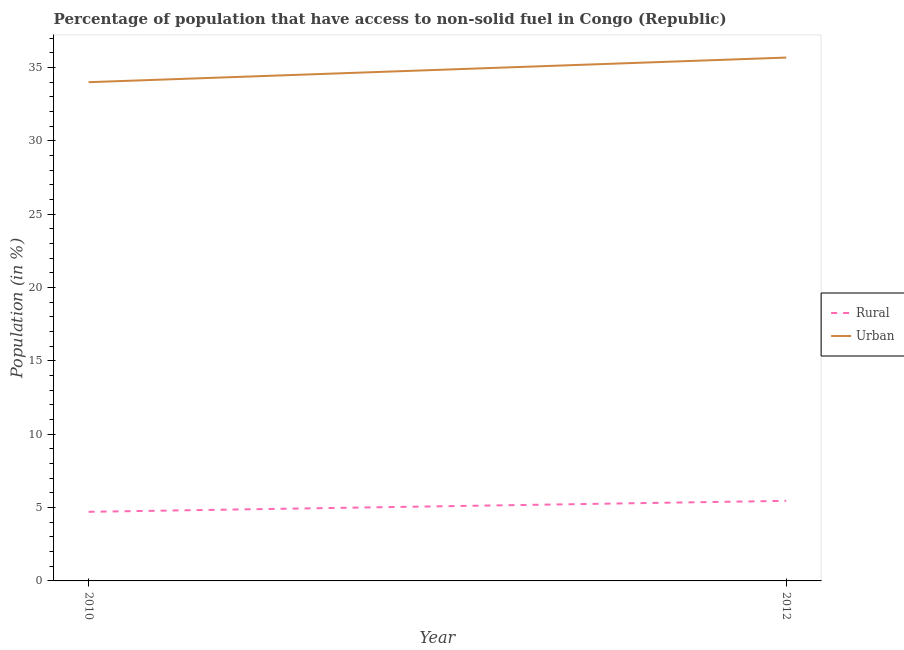How many different coloured lines are there?
Provide a short and direct response. 2. What is the urban population in 2010?
Make the answer very short. 34.01. Across all years, what is the maximum rural population?
Ensure brevity in your answer.  5.46. Across all years, what is the minimum rural population?
Keep it short and to the point. 4.71. In which year was the rural population minimum?
Your answer should be compact. 2010. What is the total rural population in the graph?
Your response must be concise. 10.17. What is the difference between the rural population in 2010 and that in 2012?
Ensure brevity in your answer.  -0.75. What is the difference between the rural population in 2012 and the urban population in 2010?
Provide a short and direct response. -28.55. What is the average urban population per year?
Offer a very short reply. 34.85. In the year 2012, what is the difference between the urban population and rural population?
Ensure brevity in your answer.  30.23. In how many years, is the rural population greater than 4 %?
Make the answer very short. 2. What is the ratio of the rural population in 2010 to that in 2012?
Make the answer very short. 0.86. Is the urban population in 2010 less than that in 2012?
Your answer should be very brief. Yes. Is the rural population strictly greater than the urban population over the years?
Make the answer very short. No. Is the rural population strictly less than the urban population over the years?
Your answer should be very brief. Yes. How many lines are there?
Offer a terse response. 2. What is the difference between two consecutive major ticks on the Y-axis?
Your answer should be compact. 5. How many legend labels are there?
Provide a succinct answer. 2. How are the legend labels stacked?
Your answer should be very brief. Vertical. What is the title of the graph?
Offer a very short reply. Percentage of population that have access to non-solid fuel in Congo (Republic). Does "Under-5(male)" appear as one of the legend labels in the graph?
Give a very brief answer. No. What is the Population (in %) in Rural in 2010?
Make the answer very short. 4.71. What is the Population (in %) of Urban in 2010?
Make the answer very short. 34.01. What is the Population (in %) of Rural in 2012?
Your answer should be very brief. 5.46. What is the Population (in %) in Urban in 2012?
Your answer should be compact. 35.69. Across all years, what is the maximum Population (in %) of Rural?
Provide a succinct answer. 5.46. Across all years, what is the maximum Population (in %) in Urban?
Ensure brevity in your answer.  35.69. Across all years, what is the minimum Population (in %) of Rural?
Your answer should be very brief. 4.71. Across all years, what is the minimum Population (in %) of Urban?
Offer a very short reply. 34.01. What is the total Population (in %) in Rural in the graph?
Provide a succinct answer. 10.17. What is the total Population (in %) of Urban in the graph?
Keep it short and to the point. 69.69. What is the difference between the Population (in %) in Rural in 2010 and that in 2012?
Your answer should be very brief. -0.75. What is the difference between the Population (in %) of Urban in 2010 and that in 2012?
Your answer should be very brief. -1.68. What is the difference between the Population (in %) of Rural in 2010 and the Population (in %) of Urban in 2012?
Offer a terse response. -30.97. What is the average Population (in %) of Rural per year?
Your answer should be very brief. 5.09. What is the average Population (in %) in Urban per year?
Provide a succinct answer. 34.85. In the year 2010, what is the difference between the Population (in %) of Rural and Population (in %) of Urban?
Keep it short and to the point. -29.3. In the year 2012, what is the difference between the Population (in %) in Rural and Population (in %) in Urban?
Provide a succinct answer. -30.23. What is the ratio of the Population (in %) in Rural in 2010 to that in 2012?
Offer a terse response. 0.86. What is the ratio of the Population (in %) of Urban in 2010 to that in 2012?
Your response must be concise. 0.95. What is the difference between the highest and the second highest Population (in %) in Rural?
Make the answer very short. 0.75. What is the difference between the highest and the second highest Population (in %) of Urban?
Give a very brief answer. 1.68. What is the difference between the highest and the lowest Population (in %) in Rural?
Ensure brevity in your answer.  0.75. What is the difference between the highest and the lowest Population (in %) of Urban?
Make the answer very short. 1.68. 